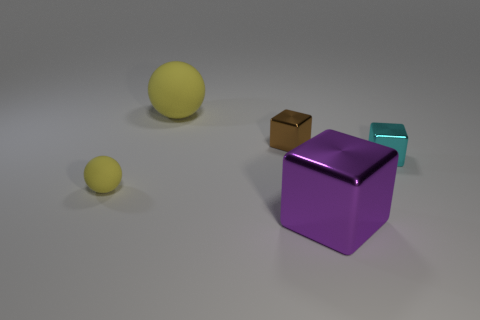Add 5 big purple rubber blocks. How many objects exist? 10 Subtract all balls. How many objects are left? 3 Subtract all big blocks. Subtract all shiny cubes. How many objects are left? 1 Add 5 tiny balls. How many tiny balls are left? 6 Add 3 small purple blocks. How many small purple blocks exist? 3 Subtract 0 brown cylinders. How many objects are left? 5 